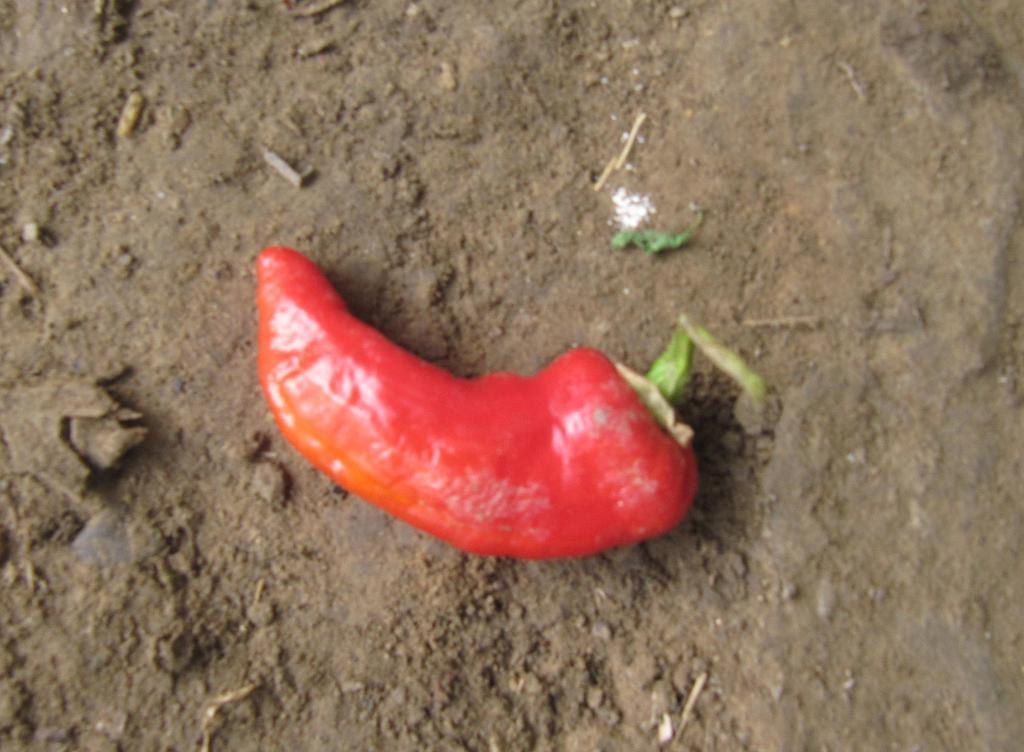Can you describe this image briefly? In this image I can see the chilli in red color and the chilli is on the ground and I can see the brown color background. 